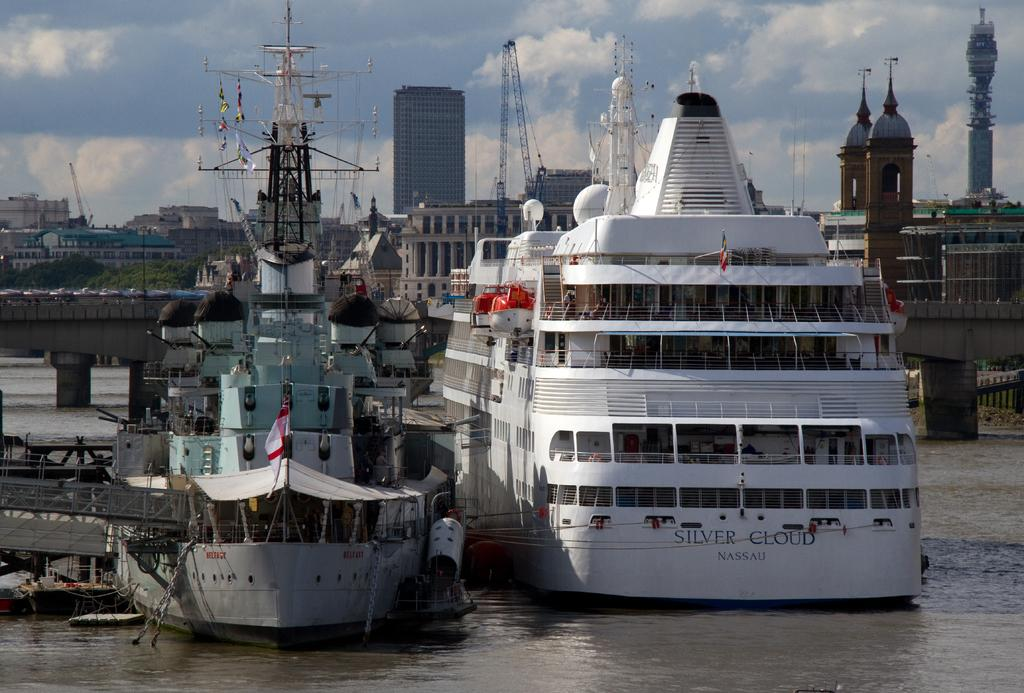<image>
Present a compact description of the photo's key features. Two boats sit in the water outside of the city, one called Silver Cloud 